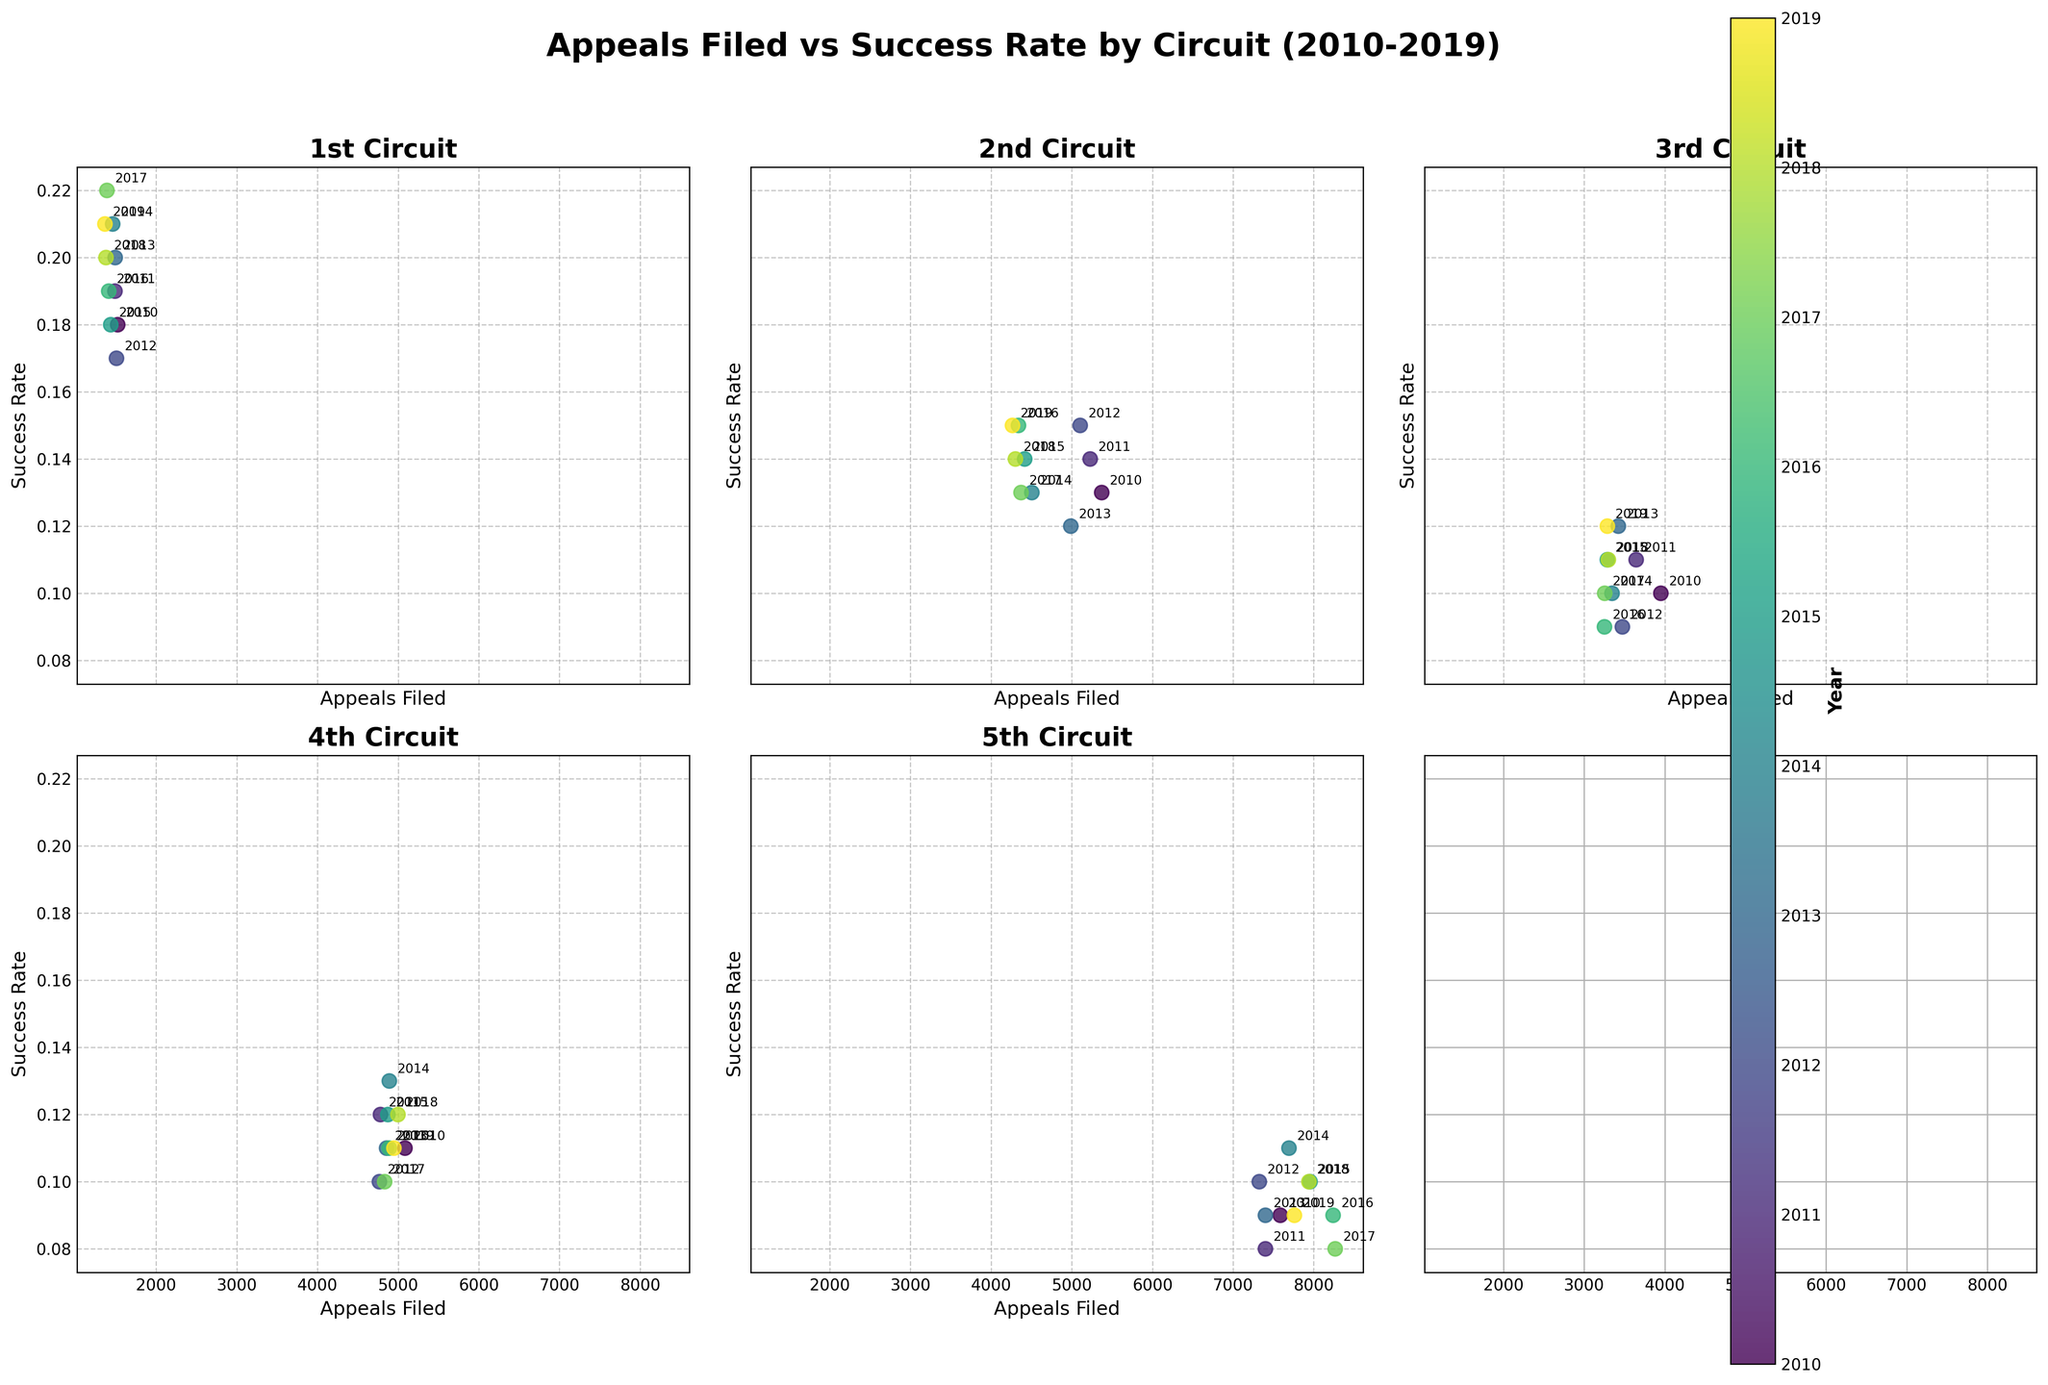Which circuit has the highest number of appeals filed in 2019? To find out which circuit has the highest number of appeals filed in 2019, identify the data points labeled '2019' and compare their positions along the x-axis. The 5th Circuit has the highest x-coordinate (7760).
Answer: 5th Circuit How did the success rate of the 1st Circuit change from 2010 to 2019? Observe the '1st Circuit' subplot and note the vertical positions of the points labeled '2010' and '2019'. The y-coordinate increases from 0.18 in 2010 to 0.21 in 2019.
Answer: It increased Which circuit had the highest success rate in 2017? Check all subplots for the data points labeled '2017' and compare their y-coordinates. The 1st Circuit data point has the highest y-coordinate (0.22).
Answer: 1st Circuit Compare the trends of appeals filed over time between the 2nd and 4th Circuits. How are they similar or different? Examine the x-axis trends for the 2nd and 4th Circuits by following the sequence of data points over the years. Both circuits show a general decline in appeals filed, but the 2nd Circuit's decline is more pronounced compared to the 4th Circuit.
Answer: Both declined; the 2nd Circuit's decline is more pronounced What is the range of success rates observed across all circuits in 2016? Identify the data points labeled '2016' in all subplots and note the minimum and maximum y-coordinates. The success rates range from 0.09 (3rd and 5th Circuits) to 0.19 (1st Circuit).
Answer: 0.09-0.19 Which circuit has shown the most improvement in success rate from 2010 to 2019? Compare the changes in y-coordinates from 2010 to 2019 for all circuits. The 1st Circuit has increased from 0.18 to 0.21 (an increase of 0.03), more than any other circuit.
Answer: 1st Circuit How many circuits have a success rate of at least 0.10 in 2014? Evaluate the y-coordinates of the data points labeled '2014' across all subplots and count those that are at least 0.10. Five circuits (all but the 3rd) have success rates of 0.10 or higher.
Answer: 5 Circuits Which year had the highest appeals filed in the 5th Circuit? Check the '5th Circuit' subplot and identify the year with the highest x-coordinate. The highest number of appeals filed is in 2016 (8240).
Answer: 2016 Did any circuit exhibit a decreasing trend in success rate from 2010 to 2019? If so, which one? Investigate the y-coordinates for each circuit's data points from 2010 to 2019 for a downward trend. The 2nd Circuit shows a fluctuating but overall declining success rate from 0.13 to 0.15, and the 5th Circuit stayed between 0.08 and 0.09 with slight fluctuations but no consistent decreasing trend.
Answer: No such consistent decreasing trend is observed Which circuit had the smallest number of appeals filed in 2017? Examine the x-coordinates of the data points labeled '2017' across all subplots and find the smallest value. The 1st Circuit has the lowest x-coordinate (1390).
Answer: 1st Circuit 